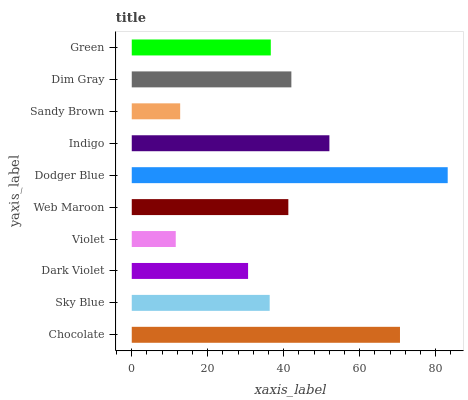Is Violet the minimum?
Answer yes or no. Yes. Is Dodger Blue the maximum?
Answer yes or no. Yes. Is Sky Blue the minimum?
Answer yes or no. No. Is Sky Blue the maximum?
Answer yes or no. No. Is Chocolate greater than Sky Blue?
Answer yes or no. Yes. Is Sky Blue less than Chocolate?
Answer yes or no. Yes. Is Sky Blue greater than Chocolate?
Answer yes or no. No. Is Chocolate less than Sky Blue?
Answer yes or no. No. Is Web Maroon the high median?
Answer yes or no. Yes. Is Green the low median?
Answer yes or no. Yes. Is Violet the high median?
Answer yes or no. No. Is Indigo the low median?
Answer yes or no. No. 